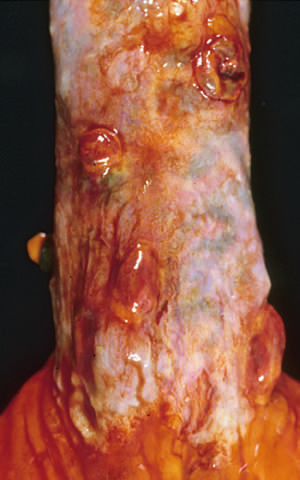where are collapsed varices present?
Answer the question using a single word or phrase. In the postmortem specimen 